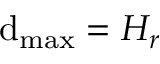Convert formula to latex. <formula><loc_0><loc_0><loc_500><loc_500>d _ { \max } = H _ { r }</formula> 